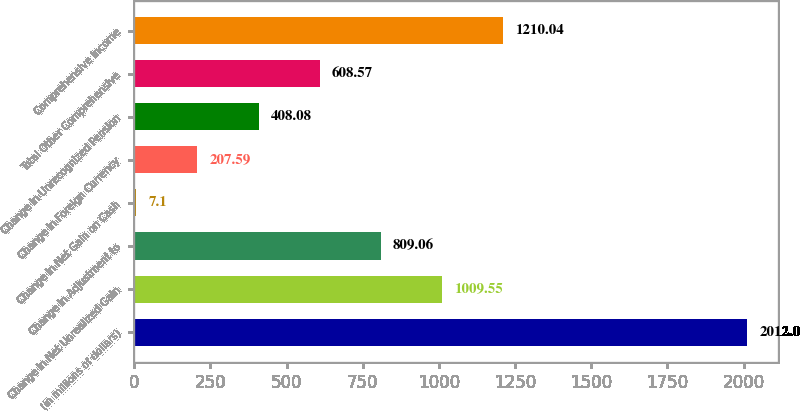Convert chart. <chart><loc_0><loc_0><loc_500><loc_500><bar_chart><fcel>(in millions of dollars)<fcel>Change in Net Unrealized Gain<fcel>Change in Adjustment to<fcel>Change in Net Gain on Cash<fcel>Change in Foreign Currency<fcel>Change in Unrecognized Pension<fcel>Total Other Comprehensive<fcel>Comprehensive Income<nl><fcel>2012<fcel>1009.55<fcel>809.06<fcel>7.1<fcel>207.59<fcel>408.08<fcel>608.57<fcel>1210.04<nl></chart> 